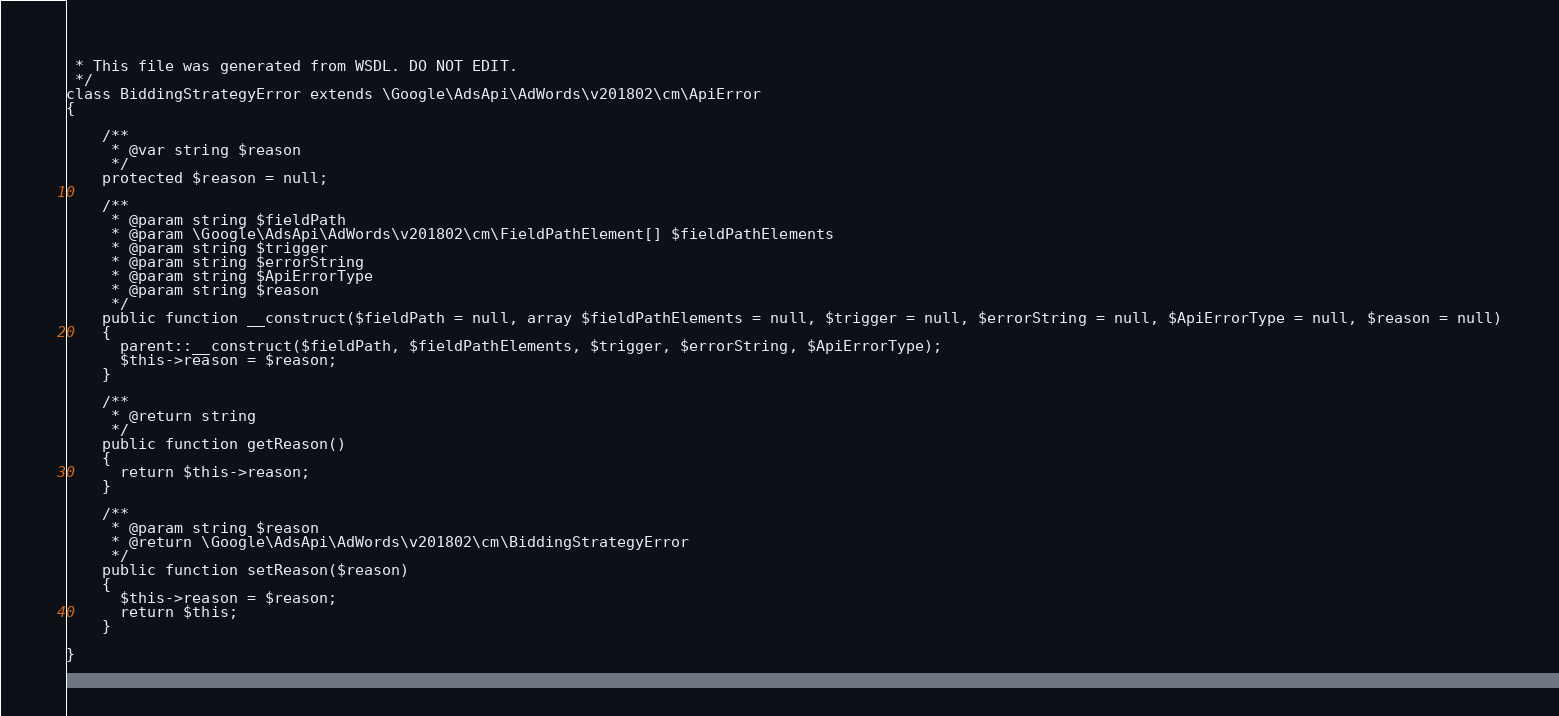<code> <loc_0><loc_0><loc_500><loc_500><_PHP_> * This file was generated from WSDL. DO NOT EDIT.
 */
class BiddingStrategyError extends \Google\AdsApi\AdWords\v201802\cm\ApiError
{

    /**
     * @var string $reason
     */
    protected $reason = null;

    /**
     * @param string $fieldPath
     * @param \Google\AdsApi\AdWords\v201802\cm\FieldPathElement[] $fieldPathElements
     * @param string $trigger
     * @param string $errorString
     * @param string $ApiErrorType
     * @param string $reason
     */
    public function __construct($fieldPath = null, array $fieldPathElements = null, $trigger = null, $errorString = null, $ApiErrorType = null, $reason = null)
    {
      parent::__construct($fieldPath, $fieldPathElements, $trigger, $errorString, $ApiErrorType);
      $this->reason = $reason;
    }

    /**
     * @return string
     */
    public function getReason()
    {
      return $this->reason;
    }

    /**
     * @param string $reason
     * @return \Google\AdsApi\AdWords\v201802\cm\BiddingStrategyError
     */
    public function setReason($reason)
    {
      $this->reason = $reason;
      return $this;
    }

}
</code> 